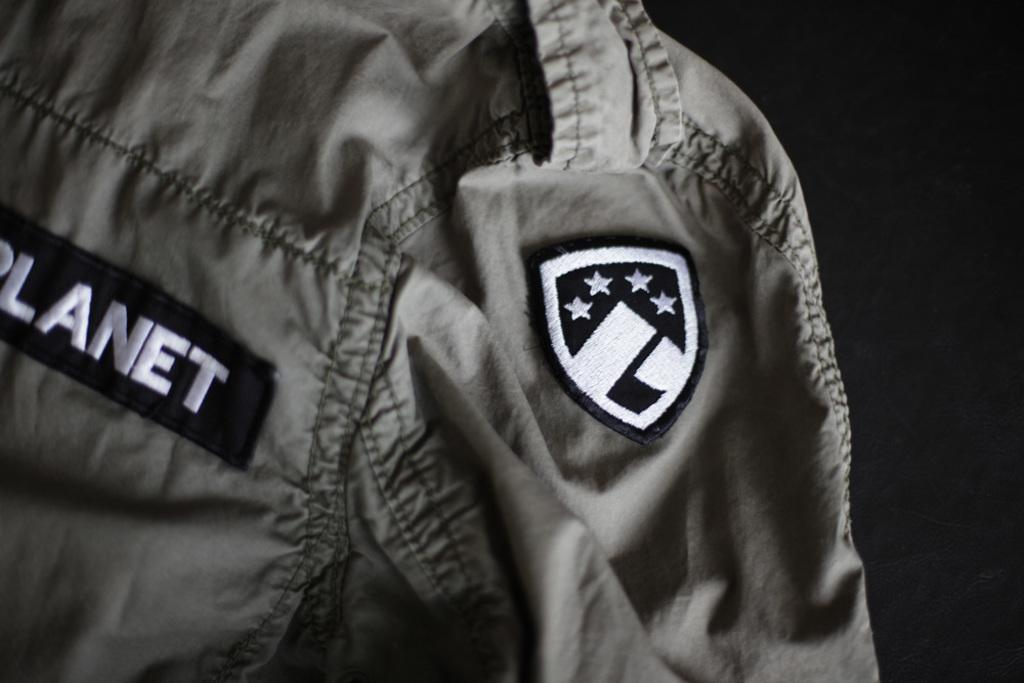<image>
Relay a brief, clear account of the picture shown. The corner of a jacket says, 'Planet', and has a patch with four stars. 